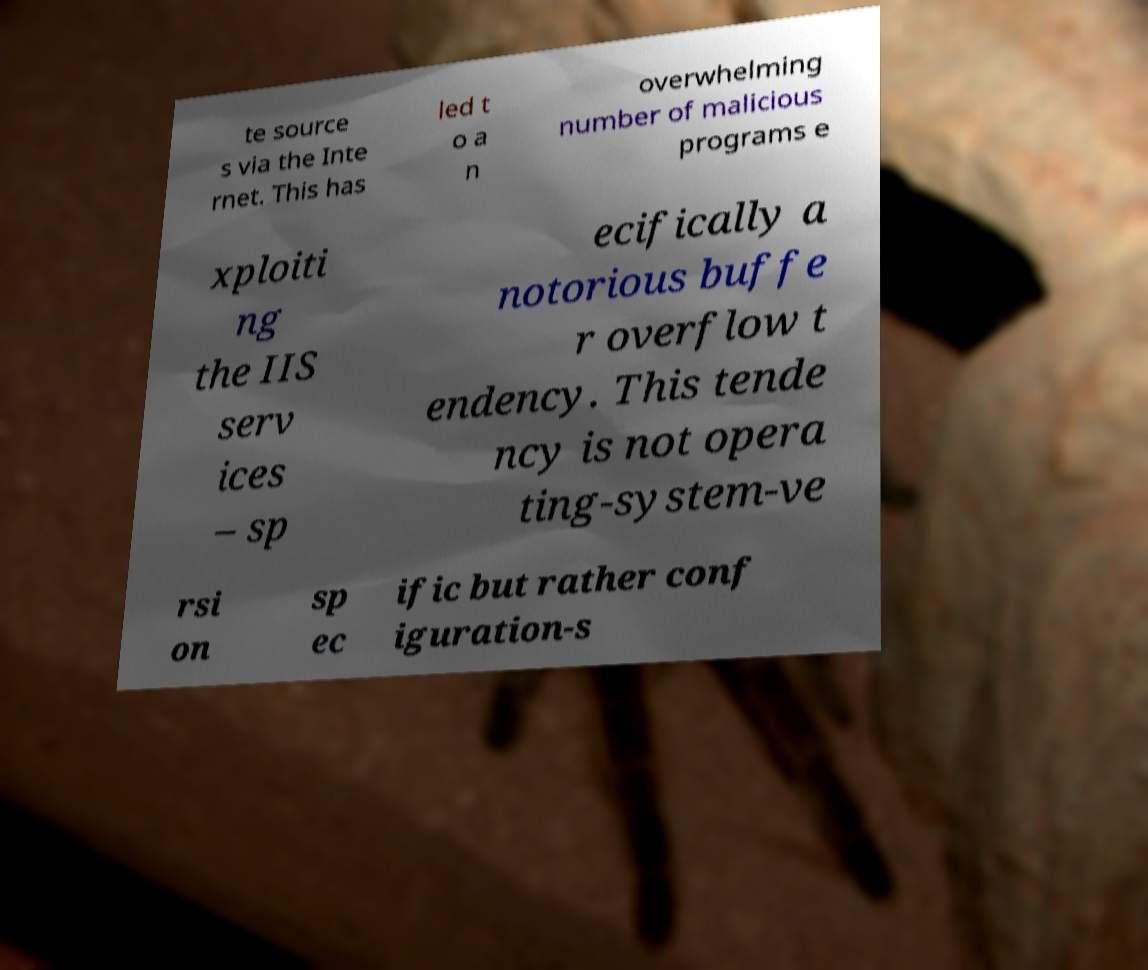For documentation purposes, I need the text within this image transcribed. Could you provide that? te source s via the Inte rnet. This has led t o a n overwhelming number of malicious programs e xploiti ng the IIS serv ices – sp ecifically a notorious buffe r overflow t endency. This tende ncy is not opera ting-system-ve rsi on sp ec ific but rather conf iguration-s 